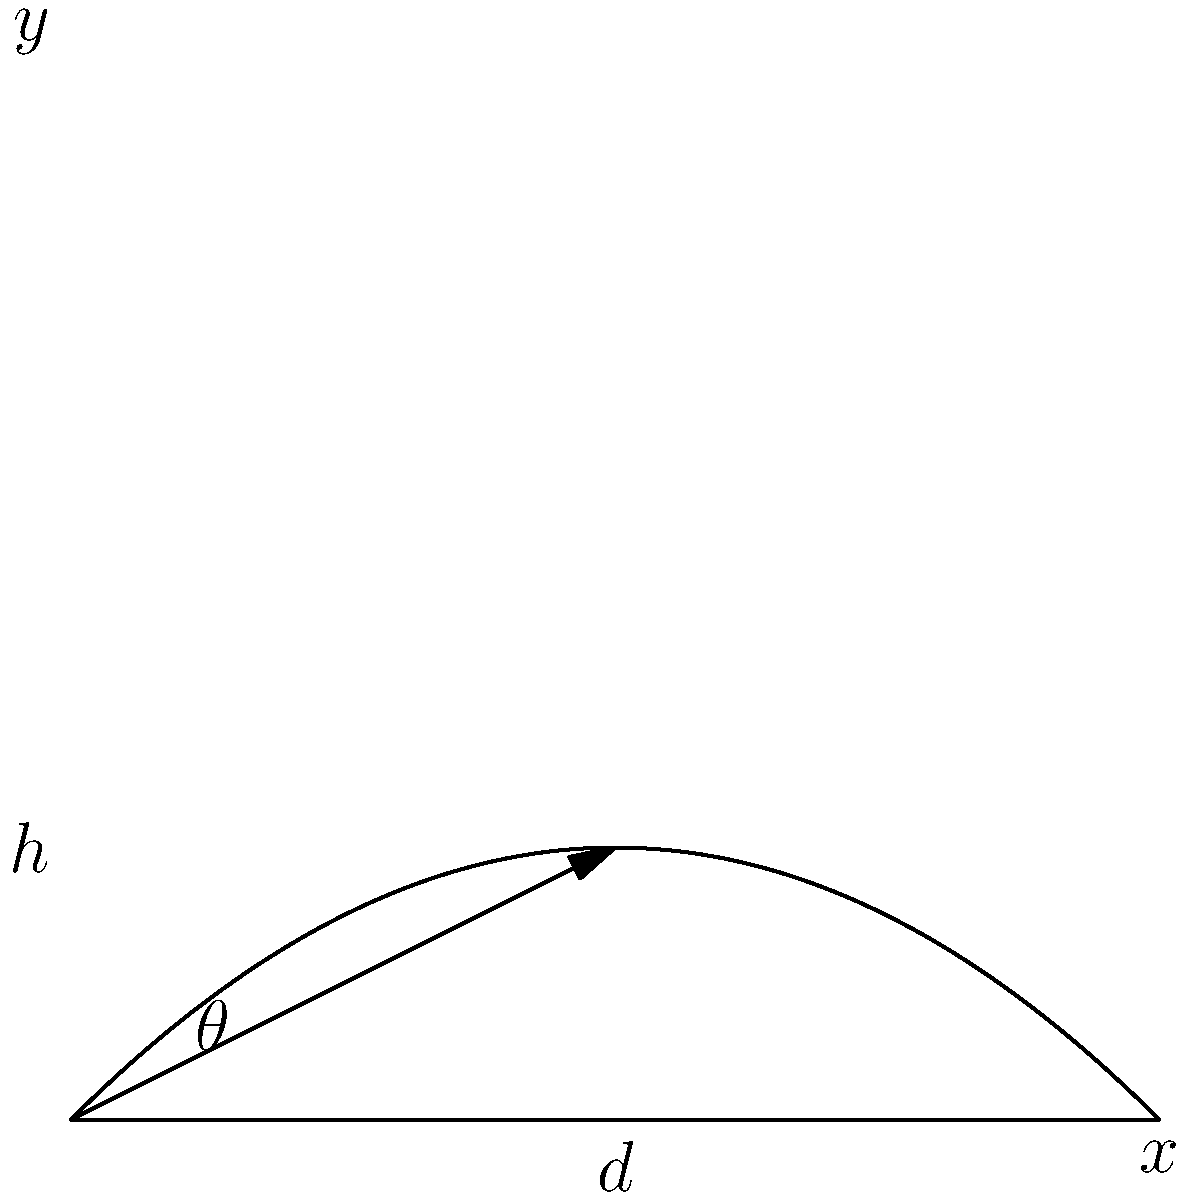You're planning to water your garden efficiently. If you hold your garden hose at a height $h$ above the ground, what angle $\theta$ should you aim the water stream to achieve the maximum horizontal distance $d$, assuming the water leaves the hose with a constant initial velocity? Let's approach this step-by-step:

1) The path of the water stream follows a parabolic trajectory due to gravity.

2) The horizontal distance $d$ is given by the equation:

   $$d = \frac{v_0^2}{g} \sin(2\theta)$$

   where $v_0$ is the initial velocity and $g$ is the acceleration due to gravity.

3) To find the maximum value of $d$, we need to maximize $\sin(2\theta)$.

4) The maximum value of sine function is 1, which occurs when its argument is 90°.

5) Therefore, $2\theta = 90°$

6) Solving for $\theta$:

   $$\theta = 45°$$

7) This result is independent of the initial velocity and the height of the hose.

8) In the context of watering your garden, aiming the hose at a 45° angle will ensure the water reaches the farthest point in your garden, helping you water efficiently without having to move around as much.
Answer: 45° 